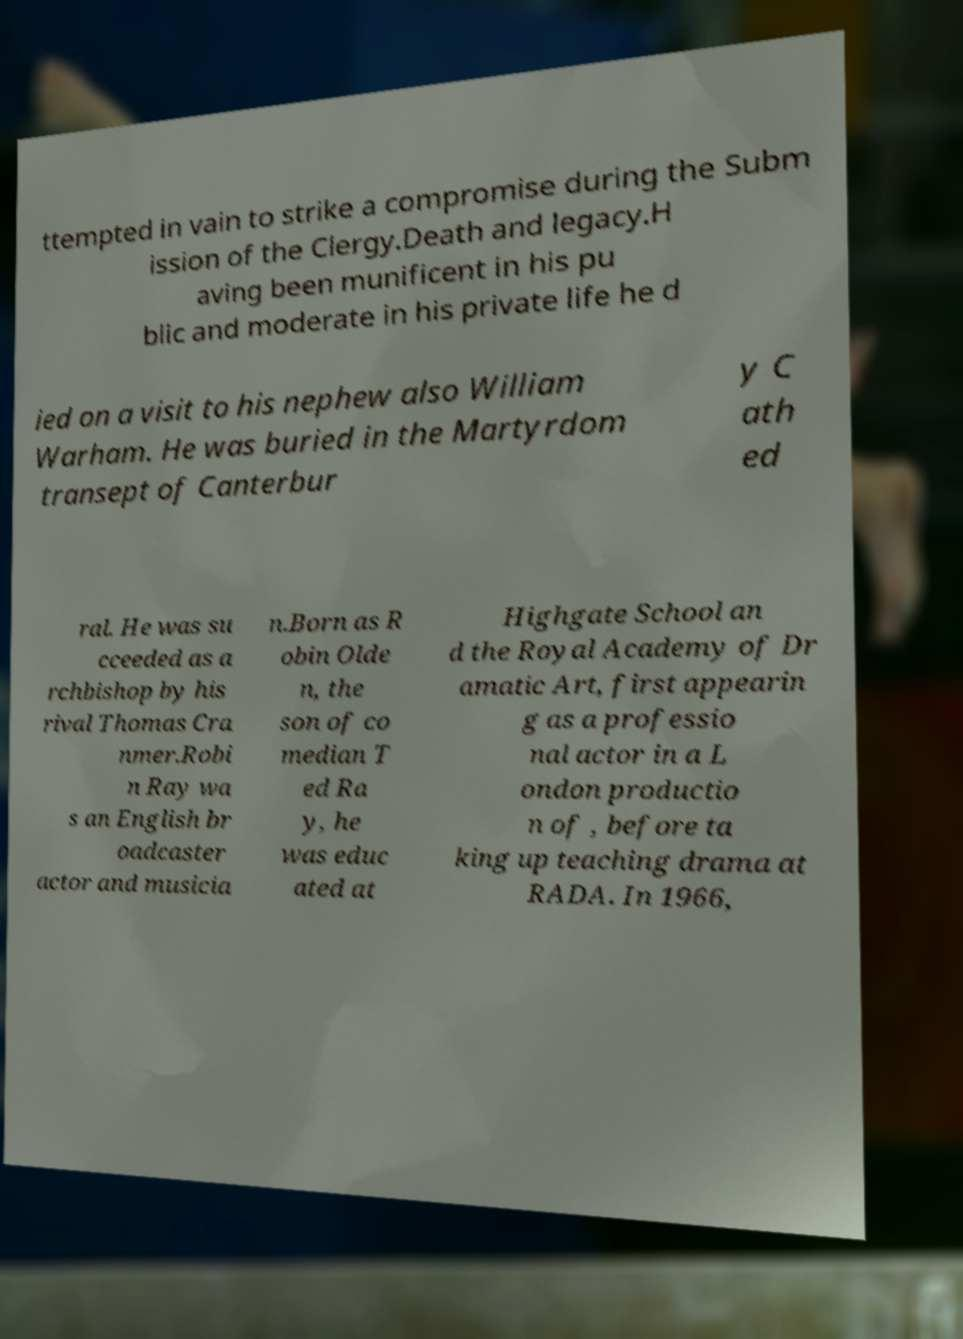Can you accurately transcribe the text from the provided image for me? ttempted in vain to strike a compromise during the Subm ission of the Clergy.Death and legacy.H aving been munificent in his pu blic and moderate in his private life he d ied on a visit to his nephew also William Warham. He was buried in the Martyrdom transept of Canterbur y C ath ed ral. He was su cceeded as a rchbishop by his rival Thomas Cra nmer.Robi n Ray wa s an English br oadcaster actor and musicia n.Born as R obin Olde n, the son of co median T ed Ra y, he was educ ated at Highgate School an d the Royal Academy of Dr amatic Art, first appearin g as a professio nal actor in a L ondon productio n of , before ta king up teaching drama at RADA. In 1966, 